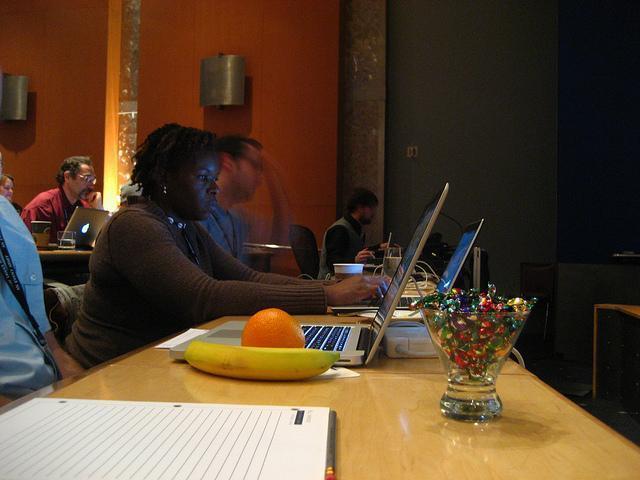How many cakes are there?
Give a very brief answer. 0. How many people are in the picture?
Give a very brief answer. 5. 